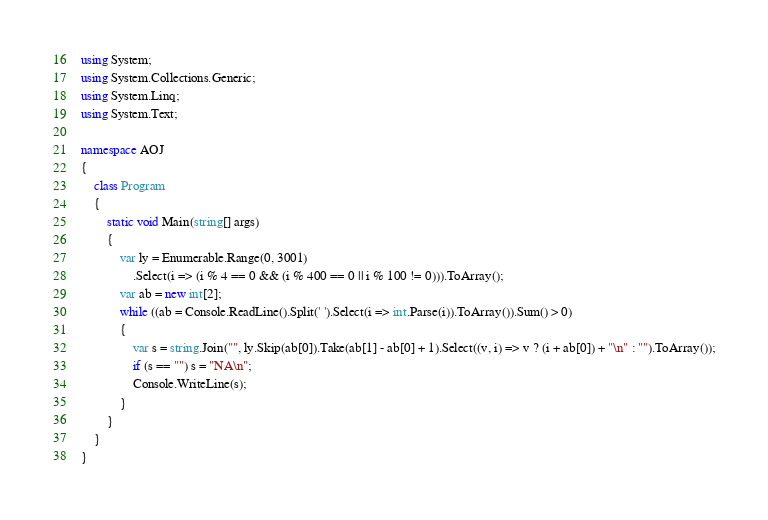Convert code to text. <code><loc_0><loc_0><loc_500><loc_500><_C#_>using System;
using System.Collections.Generic;
using System.Linq;
using System.Text;

namespace AOJ
{
	class Program
	{
		static void Main(string[] args)
		{
			var ly = Enumerable.Range(0, 3001)
				.Select(i => (i % 4 == 0 && (i % 400 == 0 || i % 100 != 0))).ToArray();
			var ab = new int[2];
			while ((ab = Console.ReadLine().Split(' ').Select(i => int.Parse(i)).ToArray()).Sum() > 0)
			{
				var s = string.Join("", ly.Skip(ab[0]).Take(ab[1] - ab[0] + 1).Select((v, i) => v ? (i + ab[0]) + "\n" : "").ToArray());
				if (s == "") s = "NA\n";
				Console.WriteLine(s);
			}
		}
	}
}</code> 